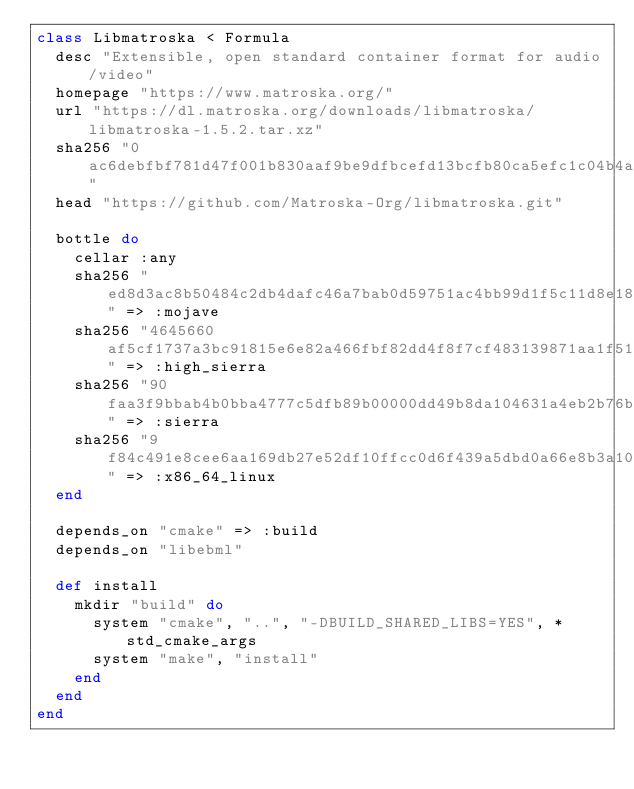<code> <loc_0><loc_0><loc_500><loc_500><_Ruby_>class Libmatroska < Formula
  desc "Extensible, open standard container format for audio/video"
  homepage "https://www.matroska.org/"
  url "https://dl.matroska.org/downloads/libmatroska/libmatroska-1.5.2.tar.xz"
  sha256 "0ac6debfbf781d47f001b830aaf9be9dfbcefd13bcfb80ca5efc1c04b4a3c962"
  head "https://github.com/Matroska-Org/libmatroska.git"

  bottle do
    cellar :any
    sha256 "ed8d3ac8b50484c2db4dafc46a7bab0d59751ac4bb99d1f5c11d8e18f71024d5" => :mojave
    sha256 "4645660af5cf1737a3bc91815e6e82a466fbf82dd4f8f7cf483139871aa1f513" => :high_sierra
    sha256 "90faa3f9bbab4b0bba4777c5dfb89b00000dd49b8da104631a4eb2b76b9e45e9" => :sierra
    sha256 "9f84c491e8cee6aa169db27e52df10ffcc0d6f439a5dbd0a66e8b3a105505706" => :x86_64_linux
  end

  depends_on "cmake" => :build
  depends_on "libebml"

  def install
    mkdir "build" do
      system "cmake", "..", "-DBUILD_SHARED_LIBS=YES", *std_cmake_args
      system "make", "install"
    end
  end
end
</code> 